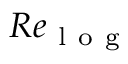Convert formula to latex. <formula><loc_0><loc_0><loc_500><loc_500>R e _ { l o g }</formula> 